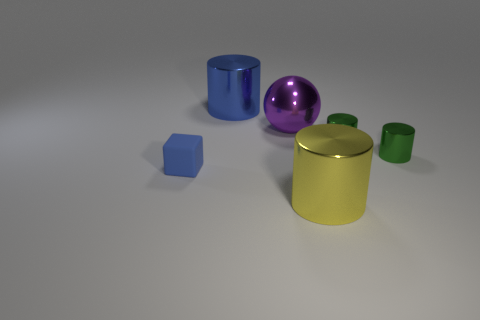If this was an image for a color study, what could we learn from it? This image could serve as a great reference for a study on how different colors interact with light and shadow. It features a range of colors from the blue cube to the purple ball, highlighting how reflective materials contrast with more matte surfaces. The study could cover color contrasts, reflections, and the impact of light on different colors and textures. 